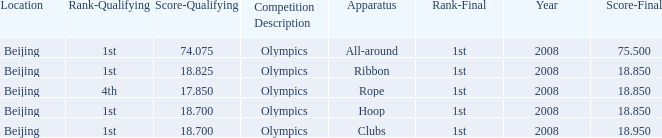What was her lowest final score with a qualifying score of 74.075? 75.5. 